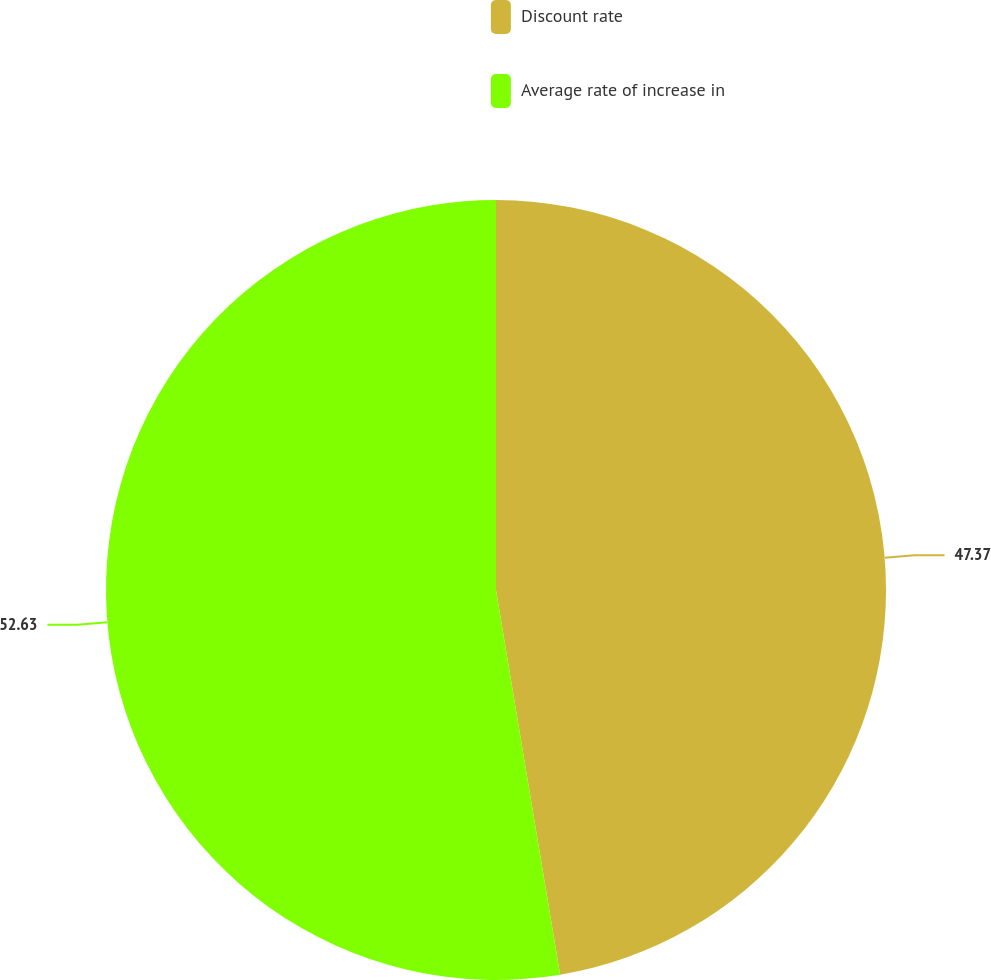Convert chart. <chart><loc_0><loc_0><loc_500><loc_500><pie_chart><fcel>Discount rate<fcel>Average rate of increase in<nl><fcel>47.37%<fcel>52.63%<nl></chart> 